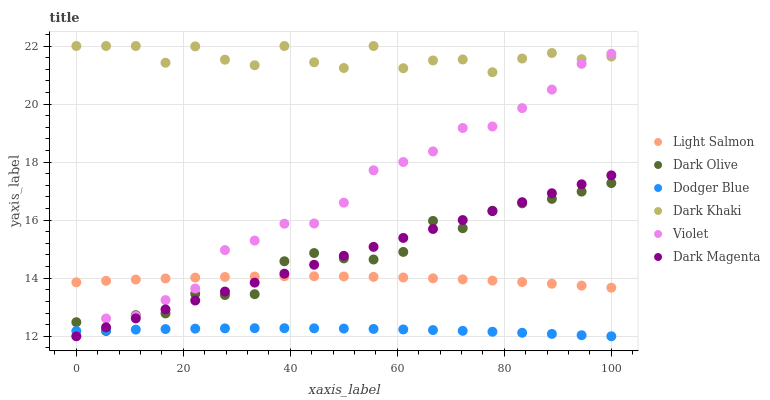Does Dodger Blue have the minimum area under the curve?
Answer yes or no. Yes. Does Dark Khaki have the maximum area under the curve?
Answer yes or no. Yes. Does Dark Magenta have the minimum area under the curve?
Answer yes or no. No. Does Dark Magenta have the maximum area under the curve?
Answer yes or no. No. Is Dark Magenta the smoothest?
Answer yes or no. Yes. Is Dark Khaki the roughest?
Answer yes or no. Yes. Is Dark Olive the smoothest?
Answer yes or no. No. Is Dark Olive the roughest?
Answer yes or no. No. Does Dark Magenta have the lowest value?
Answer yes or no. Yes. Does Dark Olive have the lowest value?
Answer yes or no. No. Does Dark Khaki have the highest value?
Answer yes or no. Yes. Does Dark Magenta have the highest value?
Answer yes or no. No. Is Dark Olive less than Dark Khaki?
Answer yes or no. Yes. Is Dark Khaki greater than Dark Magenta?
Answer yes or no. Yes. Does Violet intersect Dodger Blue?
Answer yes or no. Yes. Is Violet less than Dodger Blue?
Answer yes or no. No. Is Violet greater than Dodger Blue?
Answer yes or no. No. Does Dark Olive intersect Dark Khaki?
Answer yes or no. No. 